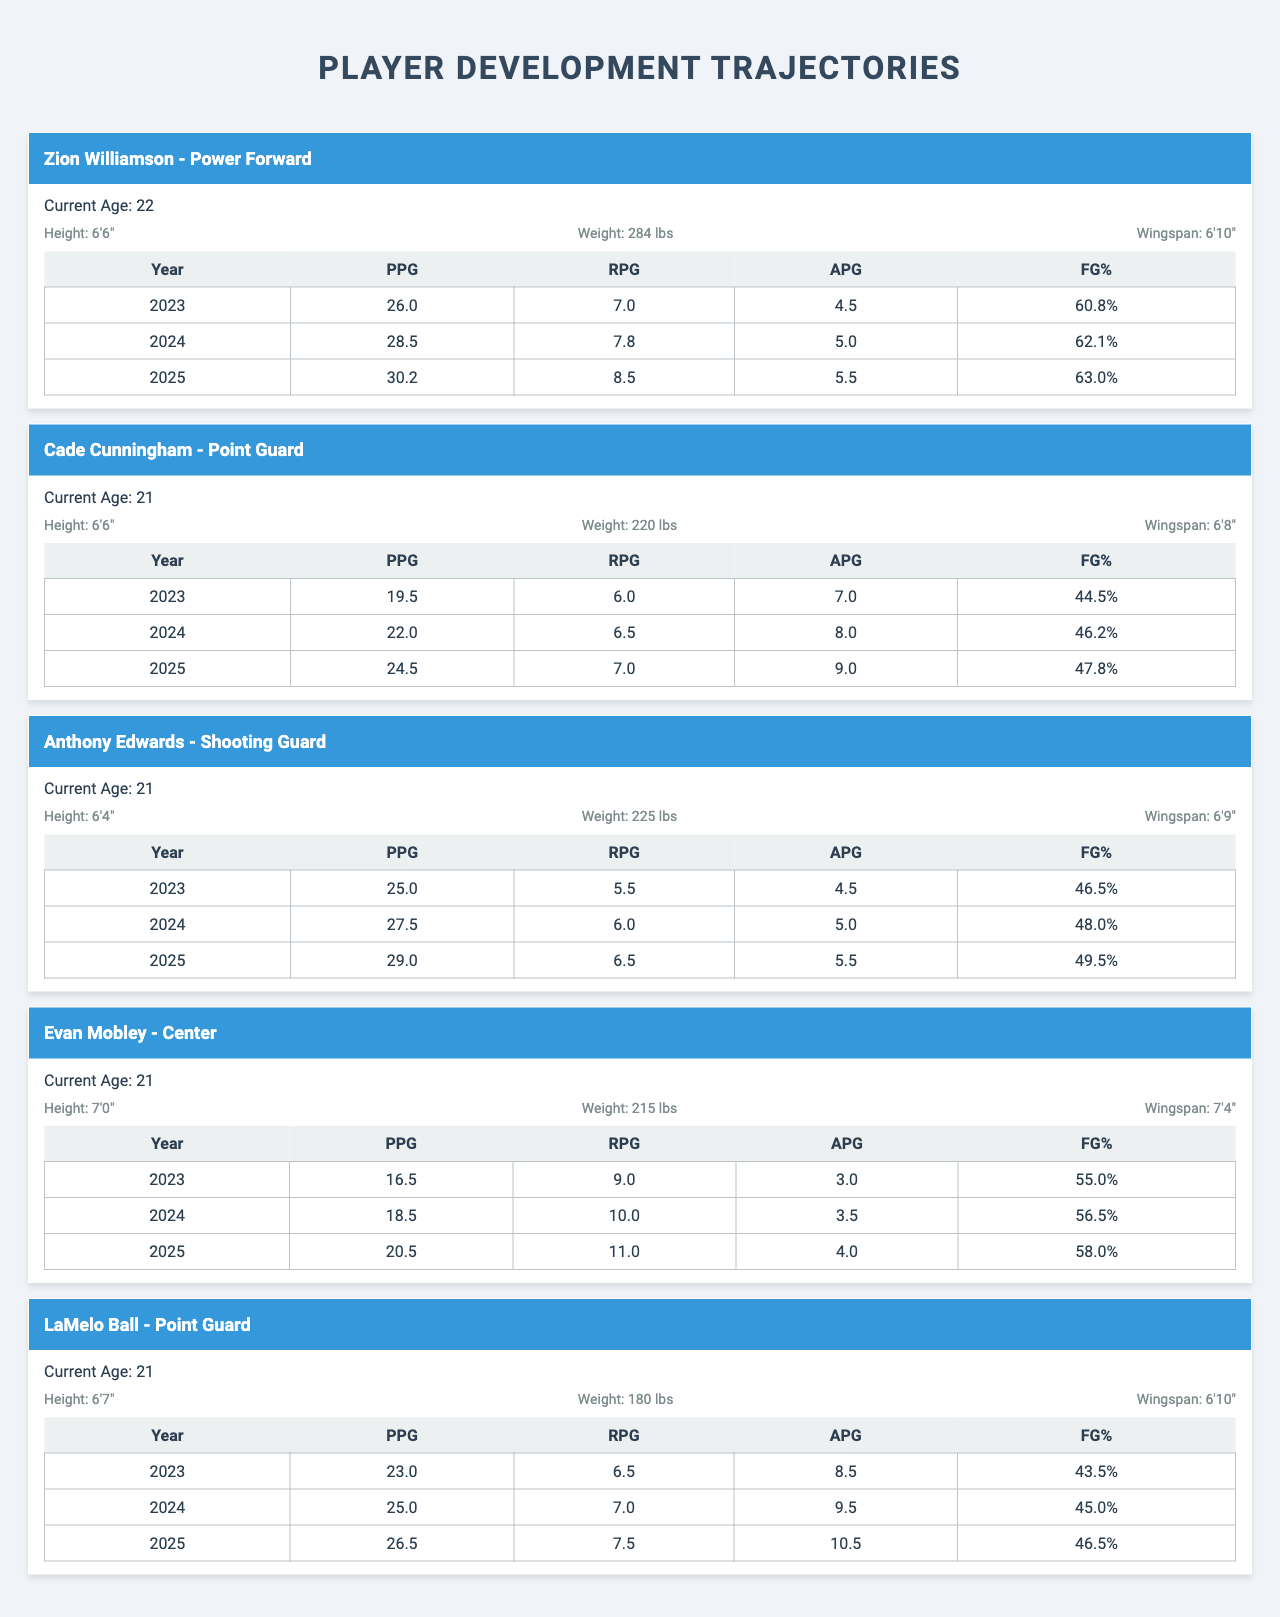What are the current ages of Cade Cunningham and Anthony Edwards? Cade Cunningham's current age is listed as 21 and Anthony Edwards' current age is also 21. Therefore, both players are the same age.
Answer: 21 Which player has the highest points per game projected for 2025? In the year 2025, Zion Williamson has the highest points per game projected at 30.2, compared to other players in that year.
Answer: 30.2 What is Evan Mobley's rebounds per game in 2024? Looking at the skill progression for Evan Mobley, his rebounds per game in 2024 is recorded as 10.0.
Answer: 10.0 Does LaMelo Ball have a higher field goal percentage in 2024 than Cade Cunningham? In 2024, LaMelo Ball's field goal percentage is 45.0, while Cade Cunningham's is 46.2. Comparing these, LaMelo Ball has a lower percentage than Cade Cunningham.
Answer: No What is the average points per game for Anthony Edwards over the three years? Anthony Edwards' points per game over the three years are 25.0, 27.5, and 29.0. To find the average, add them up: (25.0 + 27.5 + 29.0) = 81.5 and then divide by 3, resulting in 27.17.
Answer: 27.17 By how much did Zion Williamson's points per game increase from 2023 to 2025? In 2023, Zion Williamson scored 26.0 points per game, which increased to 30.2 points per game in 2025. The difference is calculated as 30.2 - 26.0 = 4.2.
Answer: 4.2 What is the total number of assists per game provided by Cade Cunningham and LaMelo Ball in 2024? Cade Cunningham's assists per game in 2024 are 8.0 and LaMelo Ball's are 9.5. Adding them gives 8.0 + 9.5 = 17.5 assists per game combined.
Answer: 17.5 Which player has the longest wingspan, and what is that measurement? Evan Mobley has the longest wingspan at 7'4". The other players have shorter wingspans.
Answer: 7'4" Is there a player who has consistently improved his rebounds per game over the three years? Reviewing the rebounds per game: Anthony Edwards (5.5 to 6.0 to 6.5), Cade Cunningham (6.0 to 6.5 to 7.0), and Evan Mobley (9.0 to 10.0 to 11.0) have all shown consistent improvement in this metric.
Answer: Yes What is the improvement in field goal percentage for Zion Williamson from 2023 to 2024? Zion Williamson's field goal percentage increased from 60.8 in 2023 to 62.1 in 2024. The improvement is 62.1 - 60.8 = 1.3 percentage points.
Answer: 1.3 